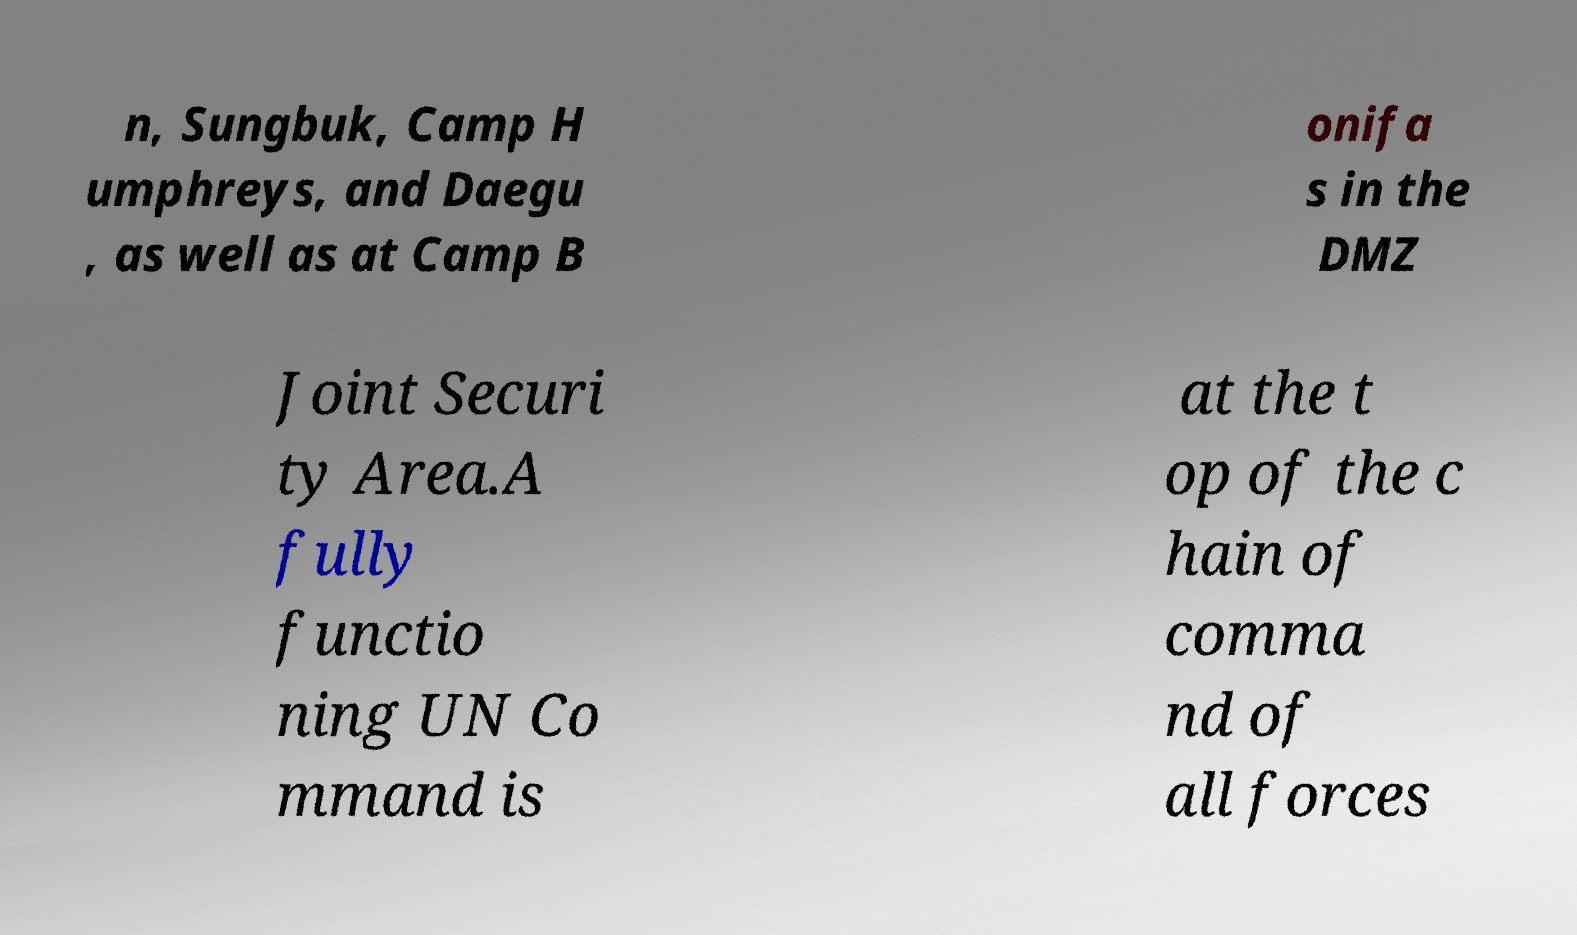What messages or text are displayed in this image? I need them in a readable, typed format. n, Sungbuk, Camp H umphreys, and Daegu , as well as at Camp B onifa s in the DMZ Joint Securi ty Area.A fully functio ning UN Co mmand is at the t op of the c hain of comma nd of all forces 